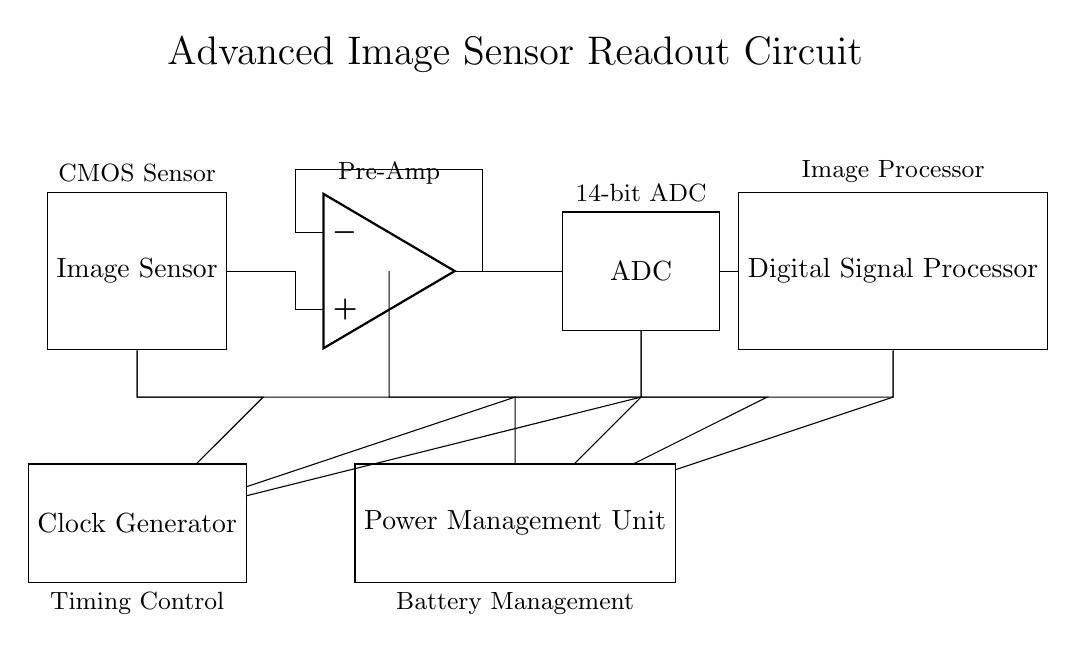What is the main component in this circuit? The main component is the Image Sensor, as it is the initial element where image capture occurs.
Answer: Image Sensor What type of ADC is used in this circuit? The ADC specified in the circuit is a 14-bit ADC, which indicates the resolution of the conversion from analog to digital signals.
Answer: 14-bit ADC How does power supply connect to the Image Sensor? Power is provided through the Power Management Unit, which connects directly to the Image Sensor, ensuring it receives the necessary voltage and current.
Answer: Power Management Unit Which component provides timing control in the circuit? The Clock Generator is responsible for providing timing control, ensuring synchronization for the components in the readout circuit.
Answer: Clock Generator What is the function of the Digital Signal Processor? The Digital Signal Processor (DSP) processes the digital signals obtained from the ADC and performs further image processing tasks.
Answer: Image processing How are the components connected to each other? The components are connected in a linear sequence starting from the Image Sensor to the Amplifier, then to the ADC, and finally to the Digital Signal Processor, indicating a flow of processing.
Answer: Linear sequence 